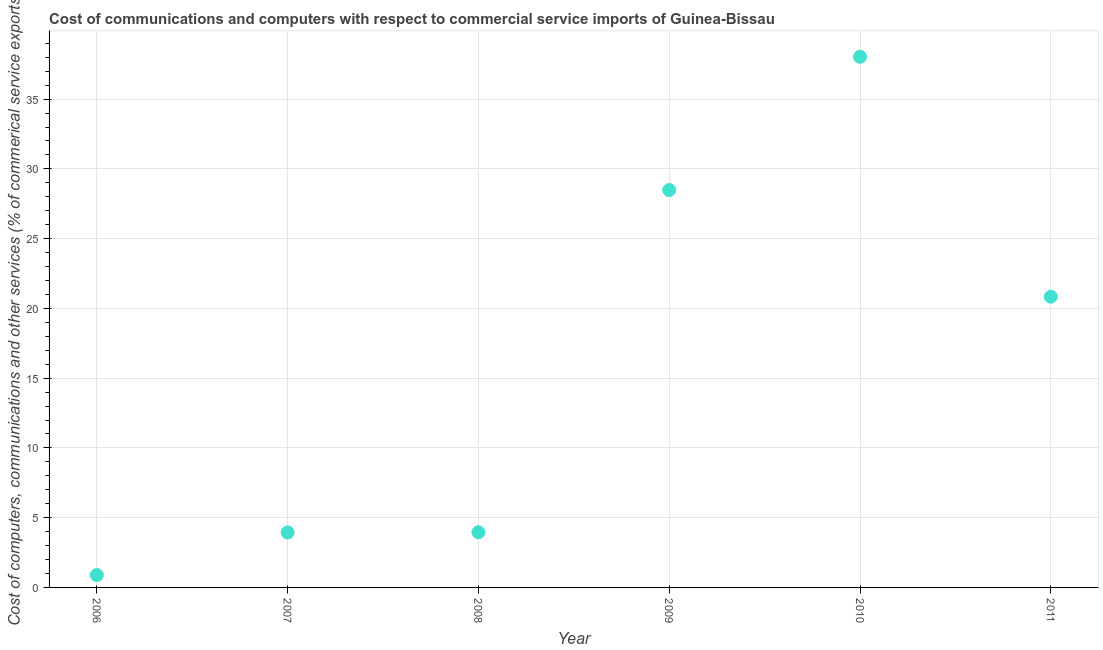What is the cost of communications in 2011?
Keep it short and to the point. 20.84. Across all years, what is the maximum cost of communications?
Make the answer very short. 38.04. Across all years, what is the minimum  computer and other services?
Ensure brevity in your answer.  0.89. What is the sum of the  computer and other services?
Provide a succinct answer. 96.15. What is the difference between the  computer and other services in 2006 and 2008?
Provide a short and direct response. -3.07. What is the average cost of communications per year?
Your answer should be very brief. 16.02. What is the median cost of communications?
Ensure brevity in your answer.  12.4. In how many years, is the cost of communications greater than 20 %?
Ensure brevity in your answer.  3. Do a majority of the years between 2007 and 2011 (inclusive) have cost of communications greater than 1 %?
Offer a very short reply. Yes. What is the ratio of the  computer and other services in 2006 to that in 2011?
Your answer should be compact. 0.04. Is the difference between the  computer and other services in 2006 and 2010 greater than the difference between any two years?
Your response must be concise. Yes. What is the difference between the highest and the second highest  computer and other services?
Your response must be concise. 9.56. What is the difference between the highest and the lowest cost of communications?
Ensure brevity in your answer.  37.15. Does the cost of communications monotonically increase over the years?
Provide a succinct answer. No. How many dotlines are there?
Your response must be concise. 1. How many years are there in the graph?
Your answer should be very brief. 6. What is the difference between two consecutive major ticks on the Y-axis?
Your answer should be compact. 5. Does the graph contain any zero values?
Provide a short and direct response. No. Does the graph contain grids?
Your response must be concise. Yes. What is the title of the graph?
Give a very brief answer. Cost of communications and computers with respect to commercial service imports of Guinea-Bissau. What is the label or title of the Y-axis?
Your answer should be very brief. Cost of computers, communications and other services (% of commerical service exports). What is the Cost of computers, communications and other services (% of commerical service exports) in 2006?
Provide a short and direct response. 0.89. What is the Cost of computers, communications and other services (% of commerical service exports) in 2007?
Your answer should be compact. 3.94. What is the Cost of computers, communications and other services (% of commerical service exports) in 2008?
Offer a very short reply. 3.96. What is the Cost of computers, communications and other services (% of commerical service exports) in 2009?
Make the answer very short. 28.48. What is the Cost of computers, communications and other services (% of commerical service exports) in 2010?
Provide a succinct answer. 38.04. What is the Cost of computers, communications and other services (% of commerical service exports) in 2011?
Provide a succinct answer. 20.84. What is the difference between the Cost of computers, communications and other services (% of commerical service exports) in 2006 and 2007?
Provide a succinct answer. -3.05. What is the difference between the Cost of computers, communications and other services (% of commerical service exports) in 2006 and 2008?
Keep it short and to the point. -3.07. What is the difference between the Cost of computers, communications and other services (% of commerical service exports) in 2006 and 2009?
Keep it short and to the point. -27.59. What is the difference between the Cost of computers, communications and other services (% of commerical service exports) in 2006 and 2010?
Your answer should be very brief. -37.15. What is the difference between the Cost of computers, communications and other services (% of commerical service exports) in 2006 and 2011?
Your answer should be compact. -19.95. What is the difference between the Cost of computers, communications and other services (% of commerical service exports) in 2007 and 2008?
Offer a terse response. -0.01. What is the difference between the Cost of computers, communications and other services (% of commerical service exports) in 2007 and 2009?
Give a very brief answer. -24.54. What is the difference between the Cost of computers, communications and other services (% of commerical service exports) in 2007 and 2010?
Your answer should be compact. -34.1. What is the difference between the Cost of computers, communications and other services (% of commerical service exports) in 2007 and 2011?
Give a very brief answer. -16.9. What is the difference between the Cost of computers, communications and other services (% of commerical service exports) in 2008 and 2009?
Your answer should be compact. -24.52. What is the difference between the Cost of computers, communications and other services (% of commerical service exports) in 2008 and 2010?
Provide a short and direct response. -34.08. What is the difference between the Cost of computers, communications and other services (% of commerical service exports) in 2008 and 2011?
Offer a very short reply. -16.88. What is the difference between the Cost of computers, communications and other services (% of commerical service exports) in 2009 and 2010?
Make the answer very short. -9.56. What is the difference between the Cost of computers, communications and other services (% of commerical service exports) in 2009 and 2011?
Offer a very short reply. 7.64. What is the difference between the Cost of computers, communications and other services (% of commerical service exports) in 2010 and 2011?
Your answer should be very brief. 17.2. What is the ratio of the Cost of computers, communications and other services (% of commerical service exports) in 2006 to that in 2007?
Provide a succinct answer. 0.23. What is the ratio of the Cost of computers, communications and other services (% of commerical service exports) in 2006 to that in 2008?
Your answer should be compact. 0.23. What is the ratio of the Cost of computers, communications and other services (% of commerical service exports) in 2006 to that in 2009?
Offer a very short reply. 0.03. What is the ratio of the Cost of computers, communications and other services (% of commerical service exports) in 2006 to that in 2010?
Your answer should be compact. 0.02. What is the ratio of the Cost of computers, communications and other services (% of commerical service exports) in 2006 to that in 2011?
Provide a succinct answer. 0.04. What is the ratio of the Cost of computers, communications and other services (% of commerical service exports) in 2007 to that in 2008?
Provide a succinct answer. 1. What is the ratio of the Cost of computers, communications and other services (% of commerical service exports) in 2007 to that in 2009?
Make the answer very short. 0.14. What is the ratio of the Cost of computers, communications and other services (% of commerical service exports) in 2007 to that in 2010?
Offer a very short reply. 0.1. What is the ratio of the Cost of computers, communications and other services (% of commerical service exports) in 2007 to that in 2011?
Keep it short and to the point. 0.19. What is the ratio of the Cost of computers, communications and other services (% of commerical service exports) in 2008 to that in 2009?
Make the answer very short. 0.14. What is the ratio of the Cost of computers, communications and other services (% of commerical service exports) in 2008 to that in 2010?
Your answer should be compact. 0.1. What is the ratio of the Cost of computers, communications and other services (% of commerical service exports) in 2008 to that in 2011?
Provide a succinct answer. 0.19. What is the ratio of the Cost of computers, communications and other services (% of commerical service exports) in 2009 to that in 2010?
Keep it short and to the point. 0.75. What is the ratio of the Cost of computers, communications and other services (% of commerical service exports) in 2009 to that in 2011?
Your answer should be compact. 1.37. What is the ratio of the Cost of computers, communications and other services (% of commerical service exports) in 2010 to that in 2011?
Offer a very short reply. 1.82. 